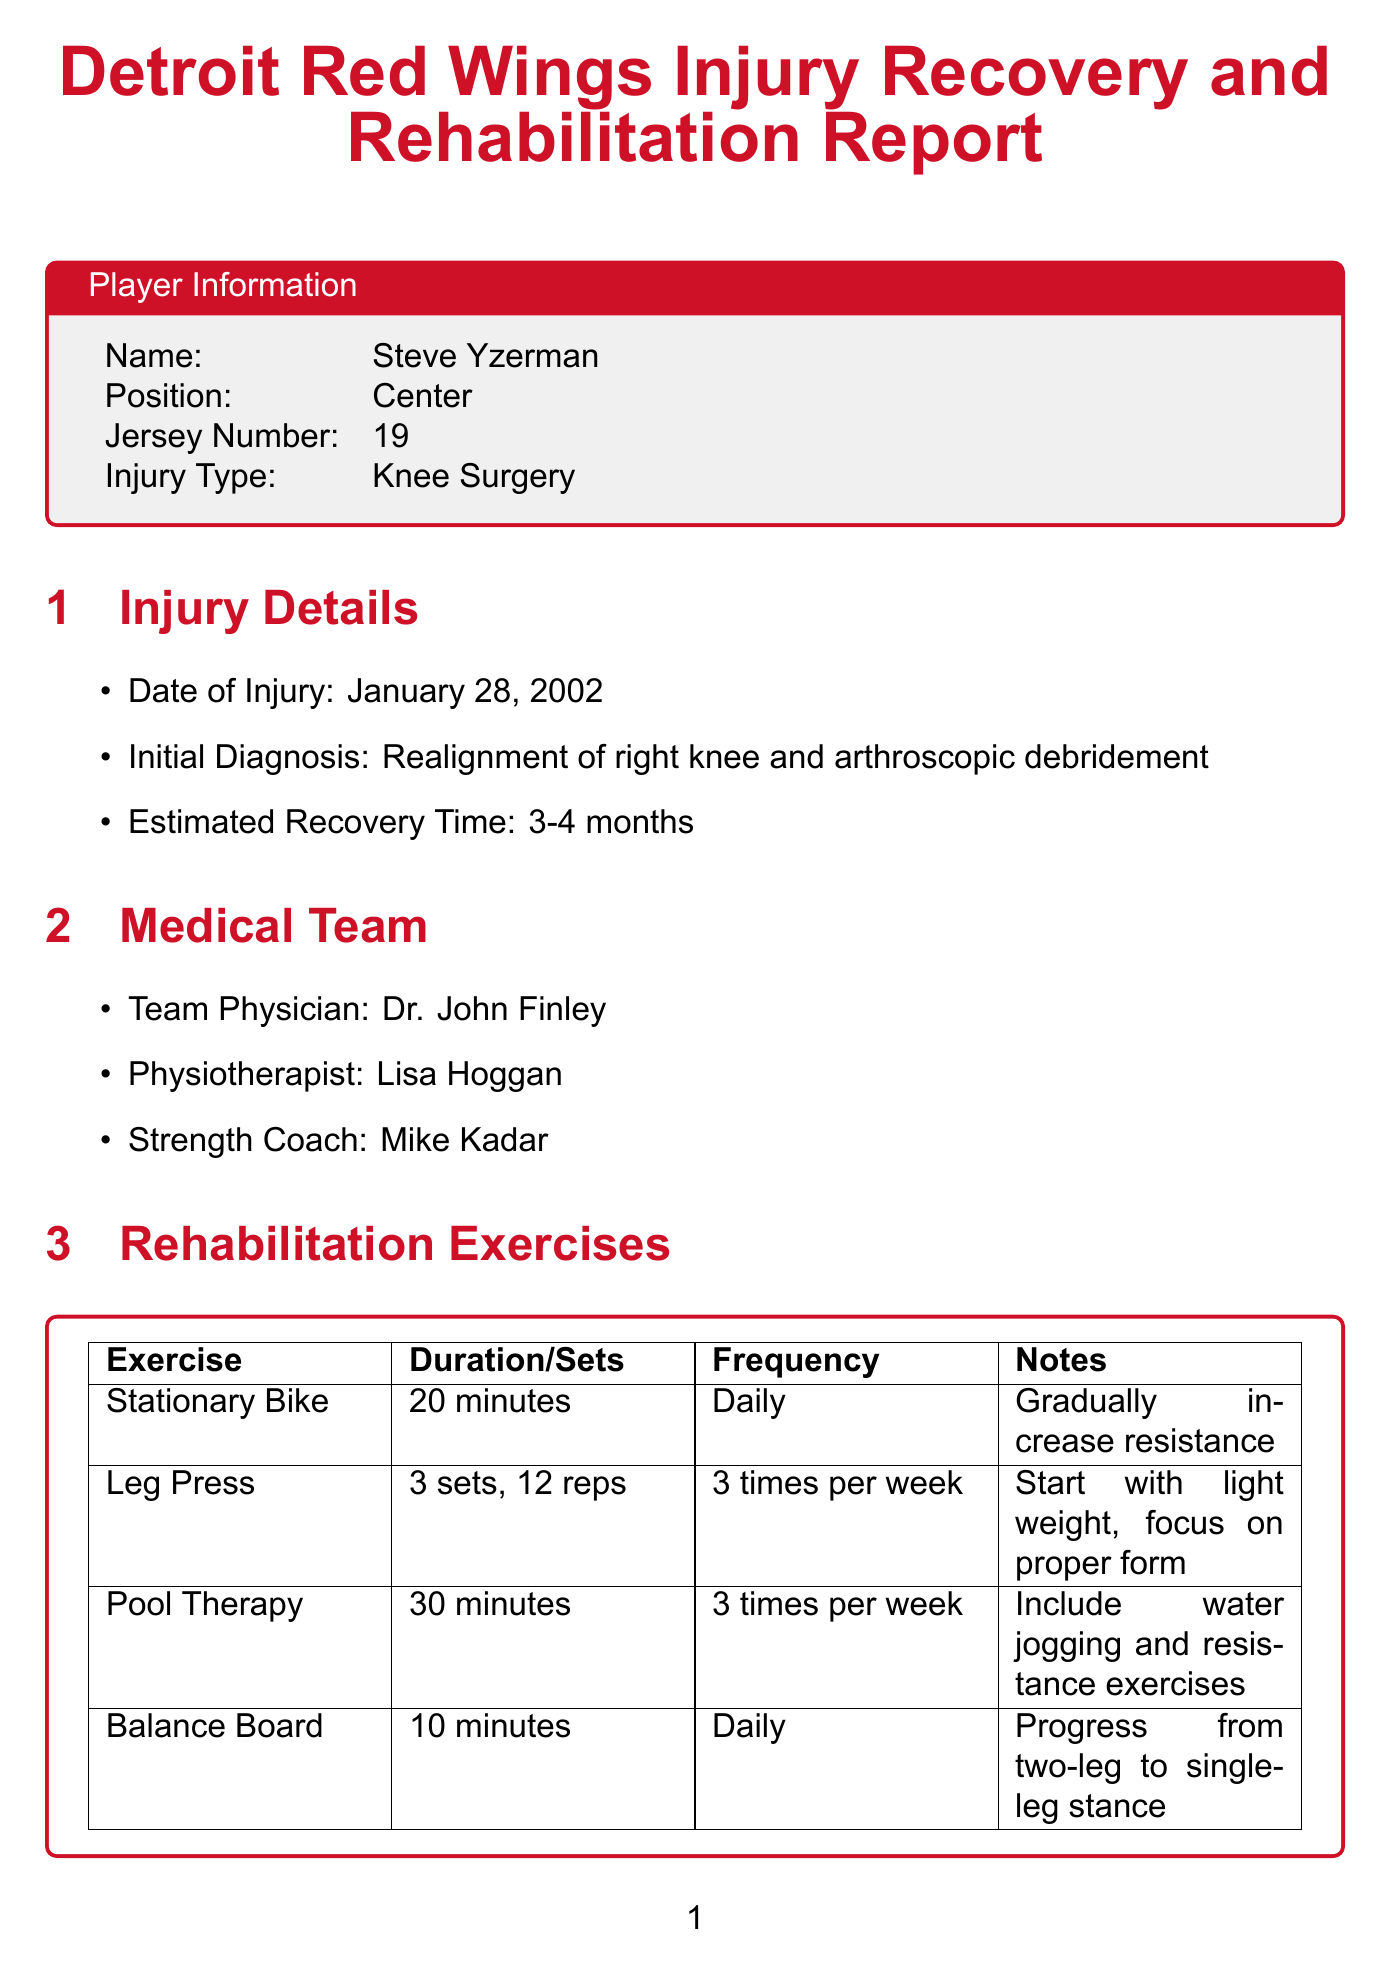what is the name of the player? The document specifies the player's name in the Player Information section.
Answer: Steve Yzerman what injury did Steve Yzerman undergo? The injury type is mentioned in the Player Information section.
Answer: Knee Surgery when did the injury occur? The document provides the date of injury in the Injury Details section.
Answer: January 28, 2002 who is the physiotherapist? The name of the physiotherapist is listed in the Medical Team section.
Answer: Lisa Hoggan what is the target date to return to game play? The target date for returning to game play is found in the Milestones section.
Answer: April 30, 2002 what exercise is done daily? The Rehabilitation Exercises section indicates the exercises along with their frequency.
Answer: Stationary Bike how many times a week does Steve Yzerman perform Pool Therapy? The frequency of Pool Therapy is specified in the Rehabilitation Exercises section.
Answer: 3 times per week what was the player feedback during week 4? Player feedback is documented under the Weekly Progress Notes section.
Answer: Feeling more stable when walking. Eager to start skating soon which player took more face-offs on the power play? The impact on special teams is discussed in the Team Impact section of the document.
Answer: Pavel Datsyuk 